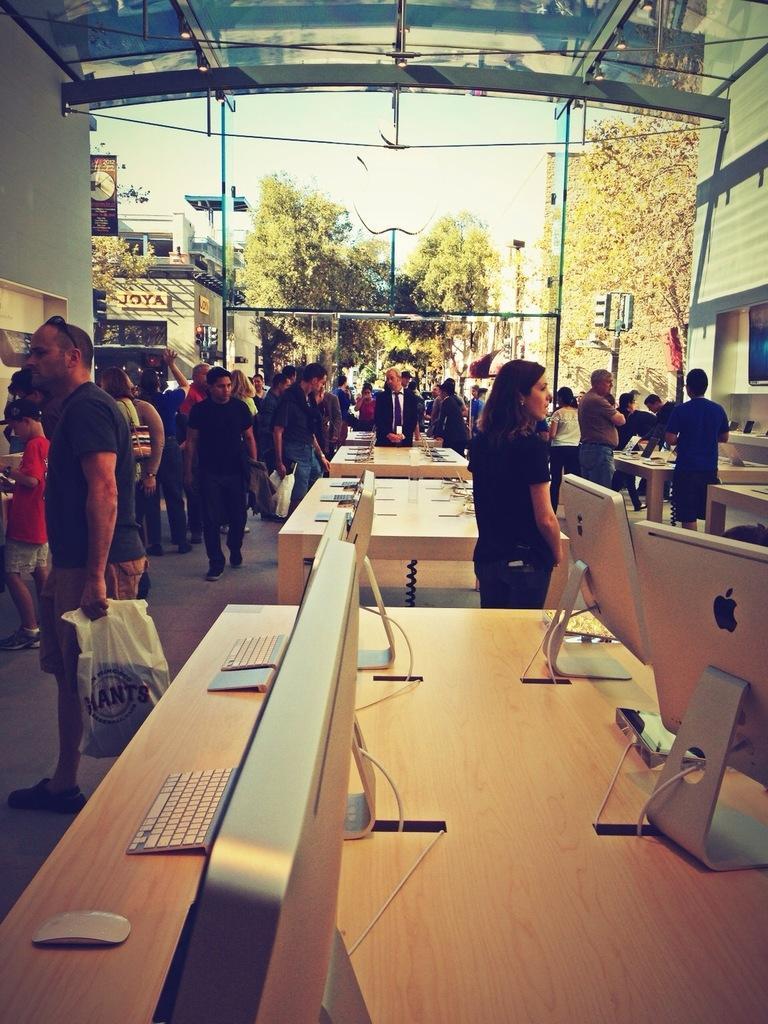Can you describe this image briefly? In this picture, we see many people moving on the road and in front of the picture, we see a table on which laptop are placed on this. Behind that, we see trees and buildings. 